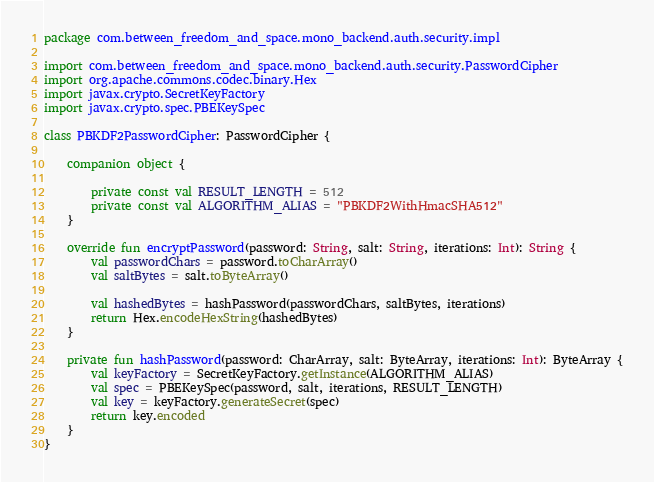<code> <loc_0><loc_0><loc_500><loc_500><_Kotlin_>package com.between_freedom_and_space.mono_backend.auth.security.impl

import com.between_freedom_and_space.mono_backend.auth.security.PasswordCipher
import org.apache.commons.codec.binary.Hex
import javax.crypto.SecretKeyFactory
import javax.crypto.spec.PBEKeySpec

class PBKDF2PasswordCipher: PasswordCipher {

    companion object {

        private const val RESULT_LENGTH = 512
        private const val ALGORITHM_ALIAS = "PBKDF2WithHmacSHA512"
    }

    override fun encryptPassword(password: String, salt: String, iterations: Int): String {
        val passwordChars = password.toCharArray()
        val saltBytes = salt.toByteArray()

        val hashedBytes = hashPassword(passwordChars, saltBytes, iterations)
        return Hex.encodeHexString(hashedBytes)
    }

    private fun hashPassword(password: CharArray, salt: ByteArray, iterations: Int): ByteArray {
        val keyFactory = SecretKeyFactory.getInstance(ALGORITHM_ALIAS)
        val spec = PBEKeySpec(password, salt, iterations, RESULT_LENGTH)
        val key = keyFactory.generateSecret(spec)
        return key.encoded
    }
}</code> 